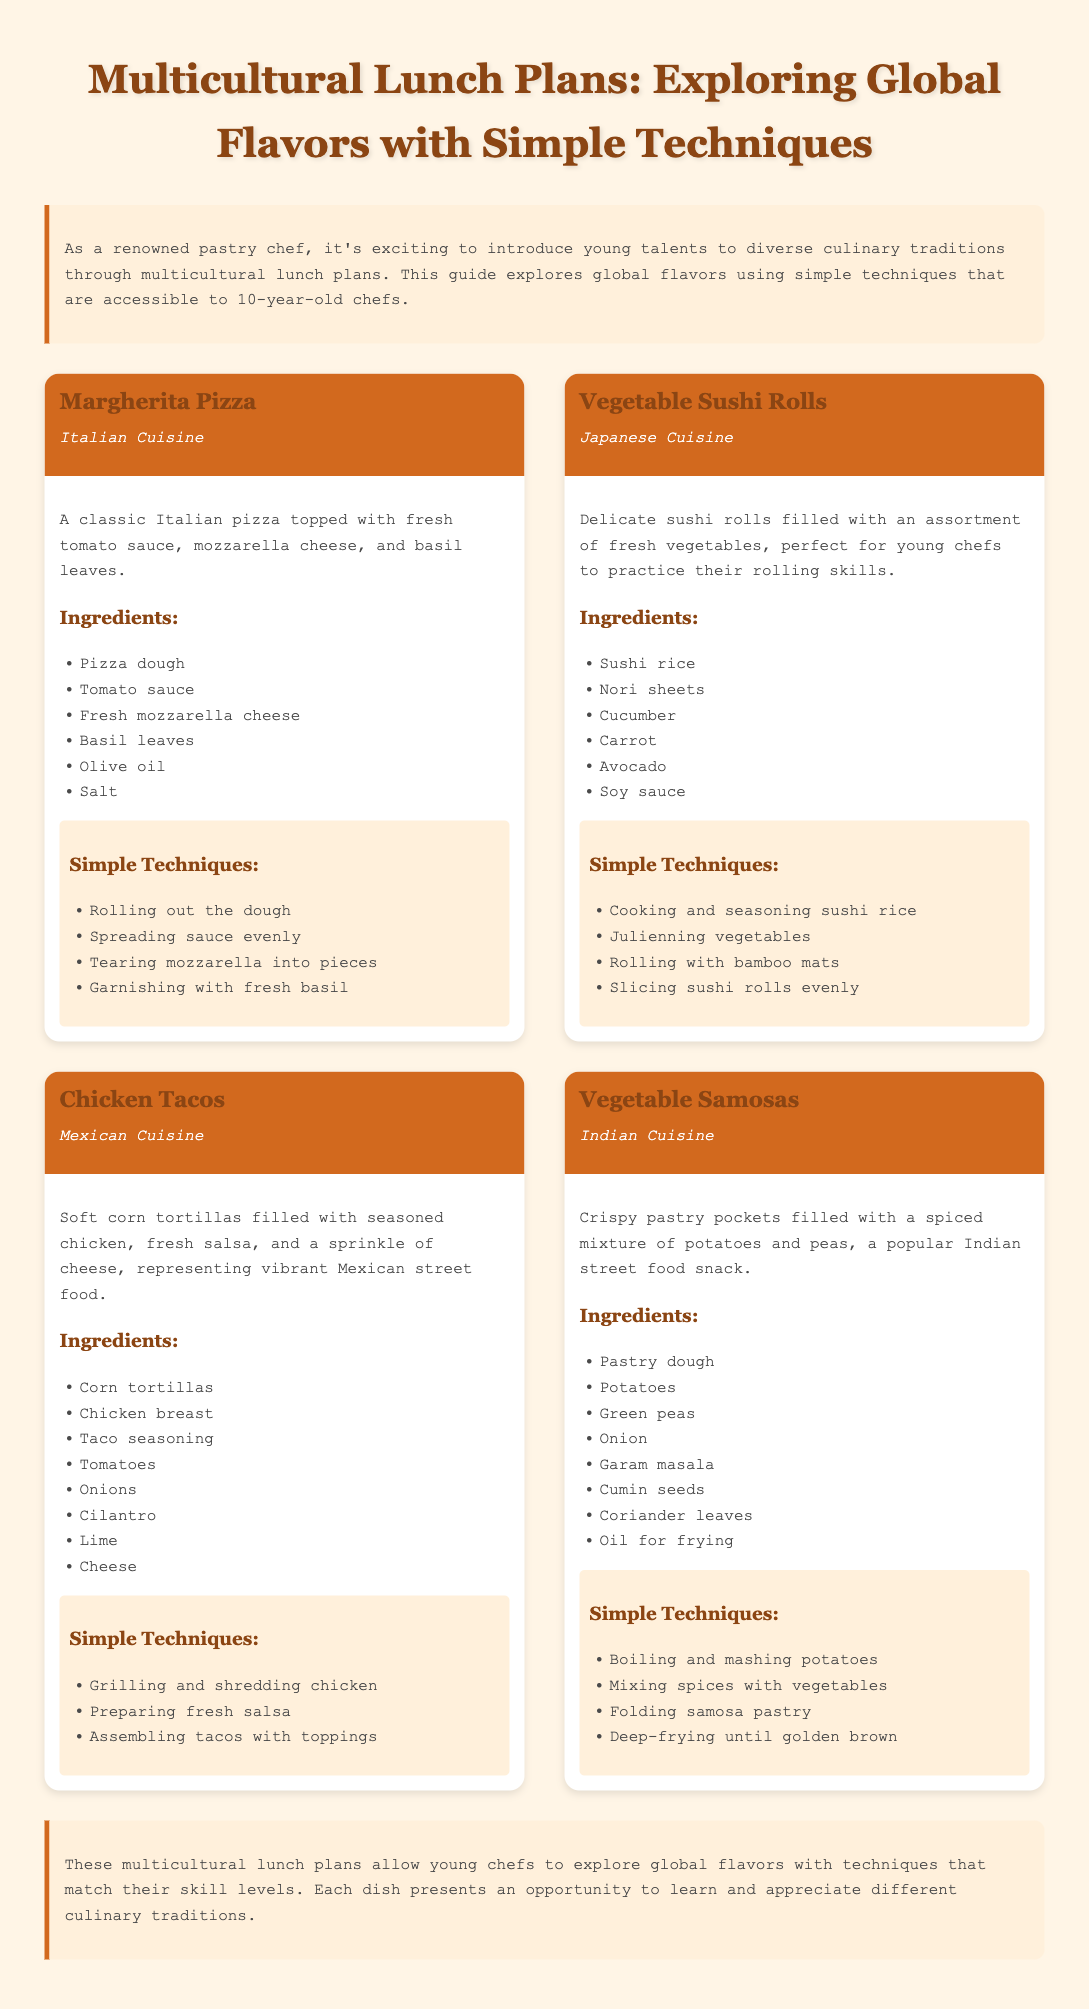What is the first dish listed in the meal plan? The first dish listed is Margherita Pizza, which is explicitly mentioned in the document under the meal plan section.
Answer: Margherita Pizza How many cuisines are represented in the meal plan? There are four different cuisines mentioned: Italian, Japanese, Mexican, and Indian as per the dish names provided.
Answer: Four What ingredient is used in both Chicken Tacos and Vegetable Samosas? The ingredient used in both dishes is onion, which is listed in the ingredients for both recipes.
Answer: Onion Which dish involves the technique of "rolling with bamboo mats"? The technique "rolling with bamboo mats" is specifically associated with Vegetable Sushi Rolls, as stated in the techniques section for that dish.
Answer: Vegetable Sushi Rolls What common ingredient is used in both Margherita Pizza and Chicken Tacos? The common ingredient found in both dishes is cheese, which is mentioned in the ingredients lists for each.
Answer: Cheese 